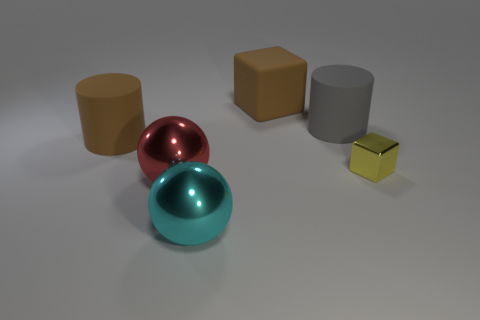Is there any other thing that is the same size as the yellow shiny block?
Offer a very short reply. No. There is a gray matte cylinder; are there any matte blocks on the left side of it?
Make the answer very short. Yes. Do the big brown rubber thing that is behind the big gray rubber cylinder and the yellow metallic thing have the same shape?
Ensure brevity in your answer.  Yes. There is a thing that is the same color as the large matte block; what material is it?
Your answer should be very brief. Rubber. What number of big things have the same color as the tiny shiny object?
Provide a succinct answer. 0. What is the shape of the big brown matte thing behind the cylinder that is right of the red metallic ball?
Make the answer very short. Cube. Is there a big red object of the same shape as the small metallic thing?
Ensure brevity in your answer.  No. There is a matte cube; is its color the same as the big matte object on the left side of the big red shiny ball?
Give a very brief answer. Yes. There is a rubber cylinder that is the same color as the matte cube; what size is it?
Provide a short and direct response. Large. Is there a cyan thing of the same size as the red metallic sphere?
Your answer should be very brief. Yes. 